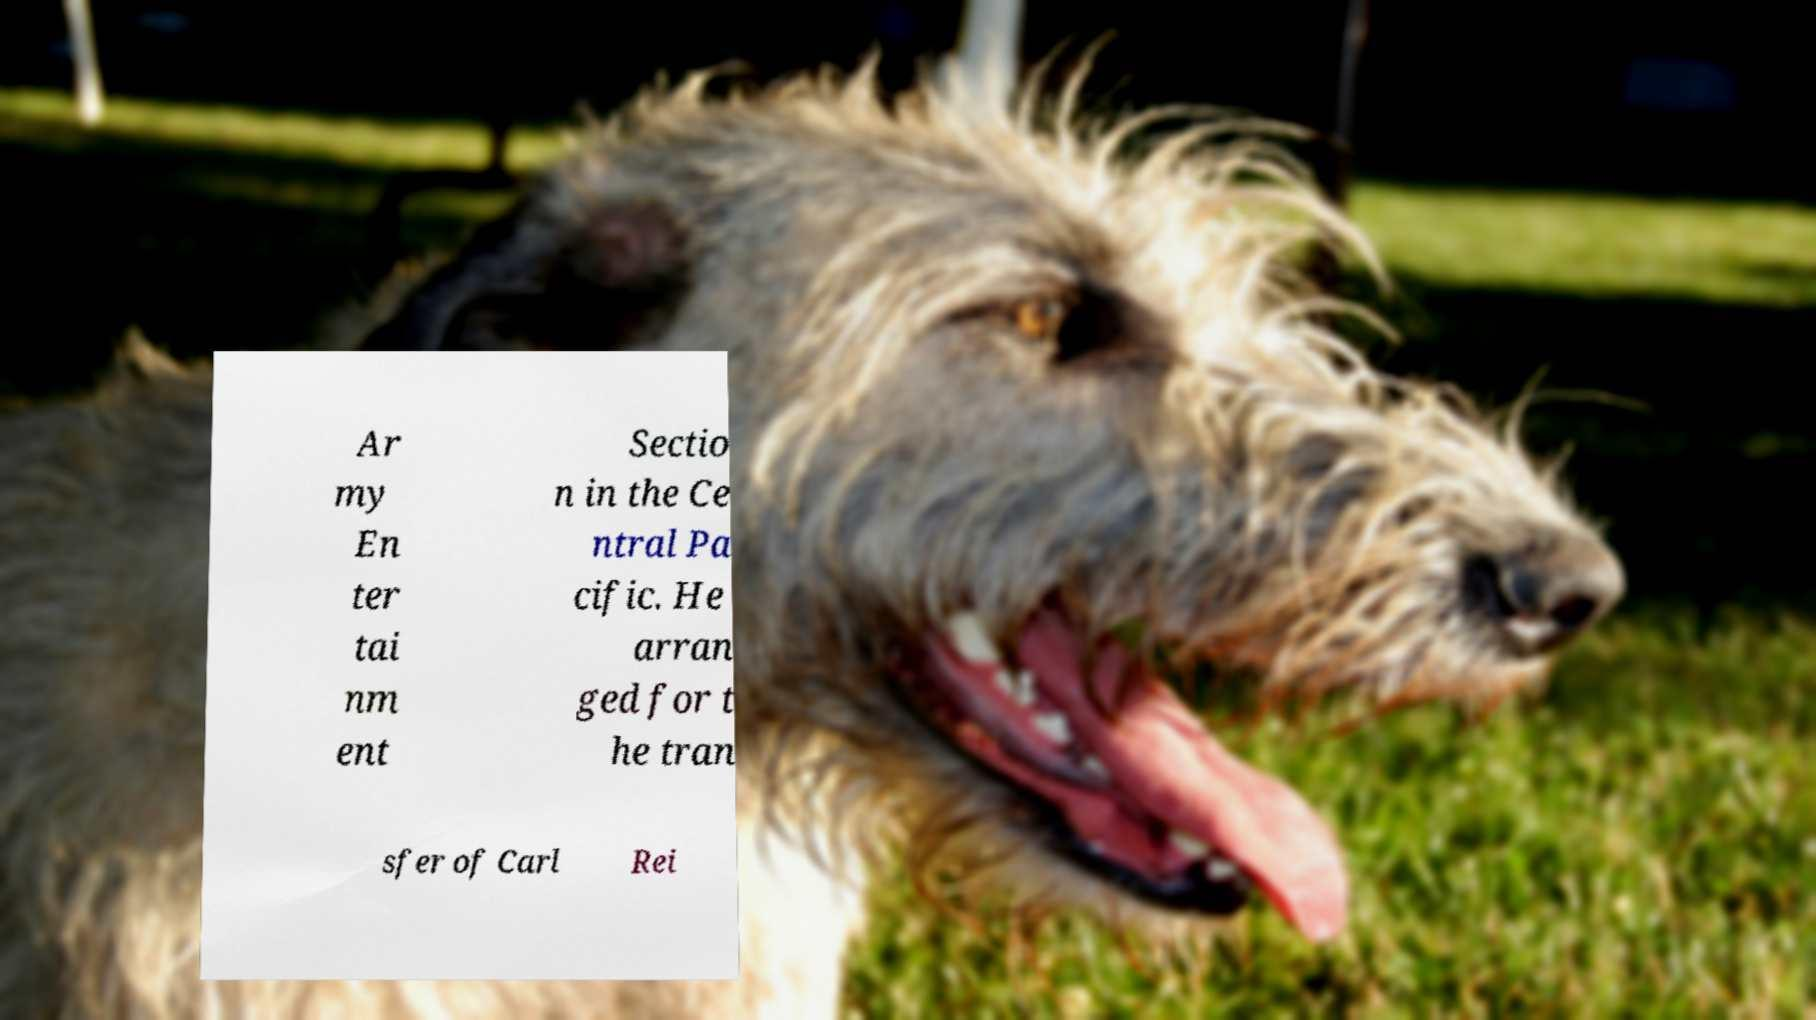Can you accurately transcribe the text from the provided image for me? Ar my En ter tai nm ent Sectio n in the Ce ntral Pa cific. He arran ged for t he tran sfer of Carl Rei 